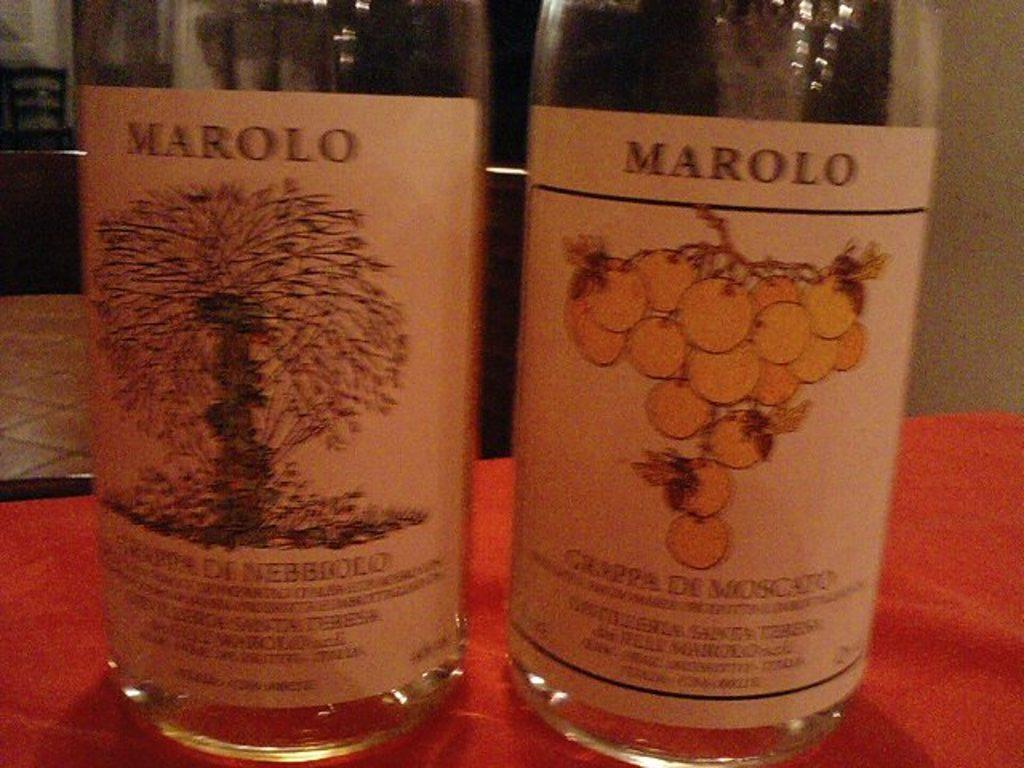How many bottles are visible in the image? There are two bottles in the image. Where are the bottles located? The bottles are on a table. What type of dust can be seen on the knee of the person in the image? There is no person present in the image, and therefore no knee or dust can be observed. 